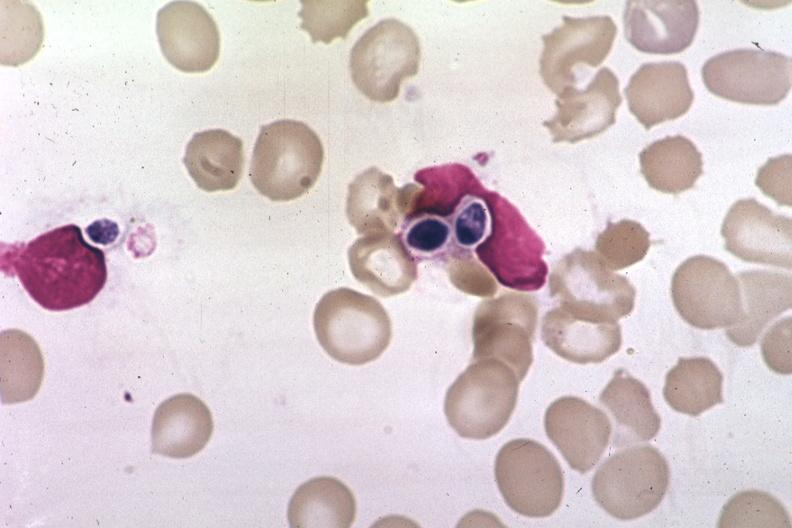s candida in peripheral blood present?
Answer the question using a single word or phrase. Yes 